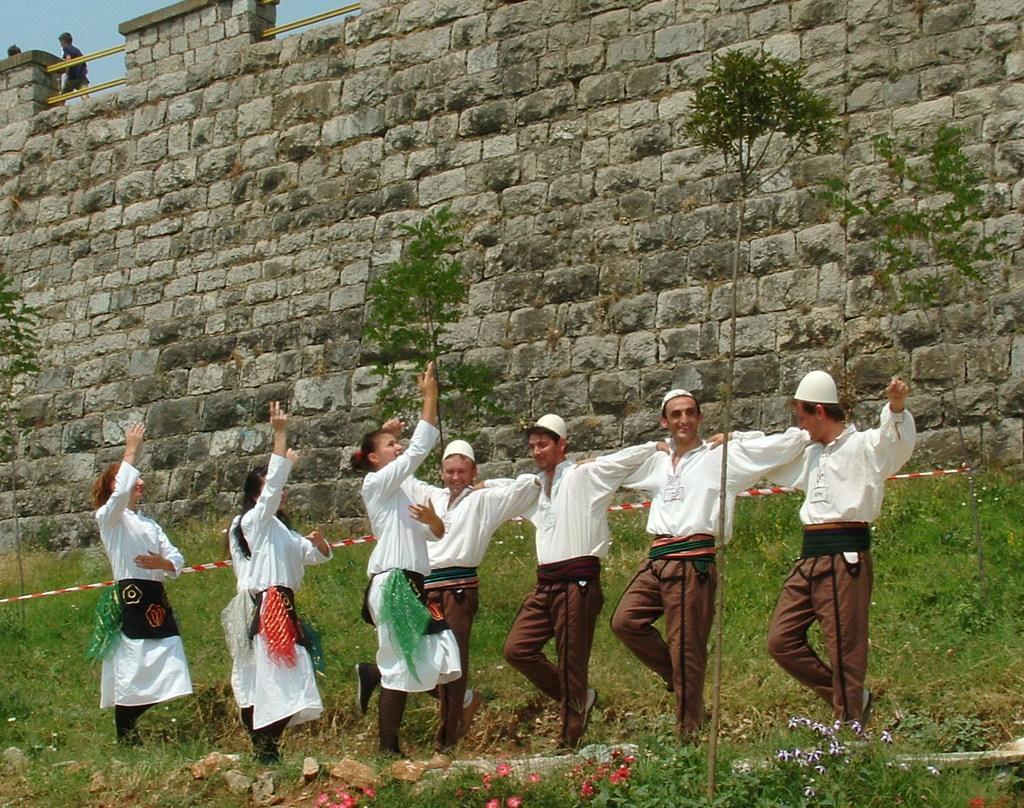Could you give a brief overview of what you see in this image? In this image there is a group of persons standing in the bottom of this image are wearing white color dress. There are some grass and plants in the background. There is a wall in the background. There are two persons standing on the top left corner of this image. 